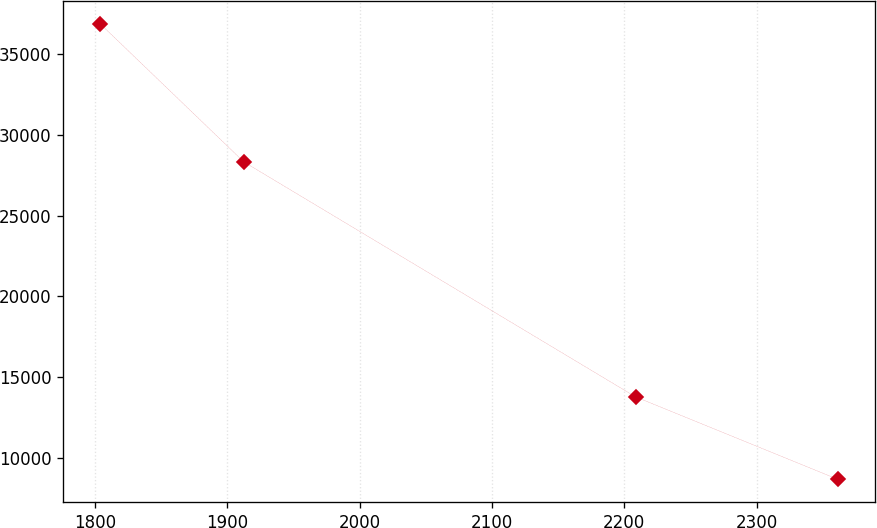Convert chart. <chart><loc_0><loc_0><loc_500><loc_500><line_chart><ecel><fcel>Unnamed: 1<nl><fcel>1803.72<fcel>36866<nl><fcel>1912.52<fcel>28313.2<nl><fcel>2208.58<fcel>13792<nl><fcel>2361.62<fcel>8690.33<nl></chart> 